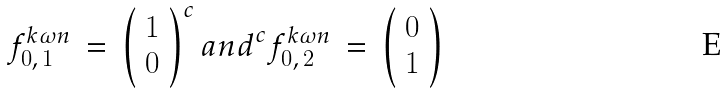<formula> <loc_0><loc_0><loc_500><loc_500>f ^ { k \omega n } _ { 0 , \, 1 } \, = \, \left ( \begin{array} { c } 1 \\ 0 \end{array} \right ) ^ { c } { a n d } ^ { c } f ^ { k \omega n } _ { 0 , \, 2 } \, = \, \left ( \begin{array} { c } 0 \\ 1 \end{array} \right )</formula> 